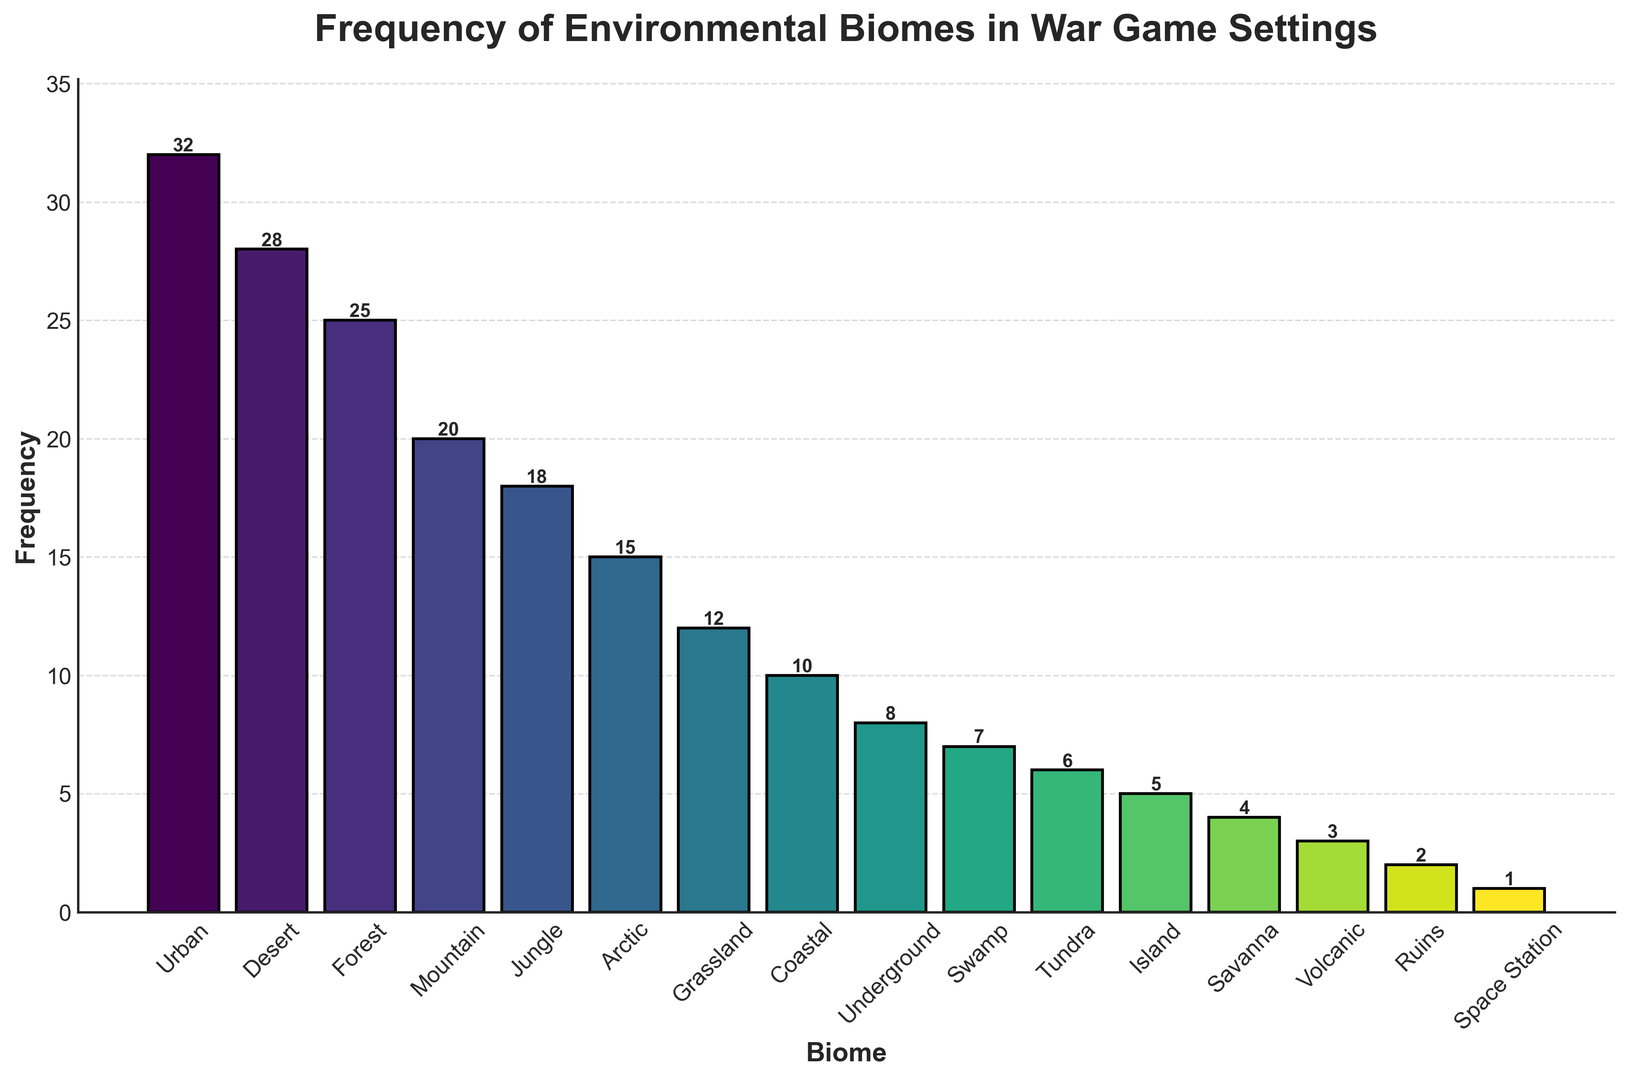What is the most frequently used biome in war game settings? The Urban biome has the tallest bar, indicating that it is used most frequently, with a frequency of 32.
Answer: Urban Which biome has the least frequency of use in the war game settings? The Space Station biome has the shortest bar, indicating that it is used the least frequently, with a frequency of 1.
Answer: Space Station How much more frequently used is Urban compared to Desert? Urban has a frequency of 32 and Desert has a frequency of 28. The difference is 32 - 28 = 4.
Answer: 4 What is the total frequency of use for Forest, Mountain, and Jungle combined? The frequencies for Forest, Mountain, and Jungle are 25, 20, and 18 respectively. The total is 25 + 20 + 18 = 63.
Answer: 63 How much more frequently is the Arctic biome used compared to the Grassland biome? The frequency of the Arctic biome is 15 and the frequency of the Grassland biome is 12. The difference is 15 - 12 = 3.
Answer: 3 Which biomes have frequencies less than 10? The Coastal, Underground, Swamp, Tundra, Island, Savanna, Volcanic, Ruins, and Space Station biomes have frequencies of 10, 8, 7, 6, 5, 4, 3, 2, and 1, respectively. All are less than 10.
Answer: Coastal, Underground, Swamp, Tundra, Island, Savanna, Volcanic, Ruins, Space Station How does the frequency of use of the Jungle biome compare to the Arctic biome? The frequency of the Jungle biome is 18 and the frequency of the Arctic biome is 15. Jungle is used more frequently by a difference of 18 - 15 = 3.
Answer: Jungle is used 3 more times What is the average frequency of use across all biomes? Adding all frequencies: 32 + 28 + 25 + 20 + 18 + 15 + 12 + 10 + 8 + 7 + 6 + 5 + 4 + 3 + 2 + 1 = 196. There are 17 biomes, so the average frequency is 196 / 17 ≈ 11.53.
Answer: 11.53 Which biome frequencies are more than twice that of the Island biome? Twice the frequency of the Island biome is 2 * 5 = 10. Biomes with frequencies greater than 10 are Urban (32), Desert (28), Forest (25), Mountain (20), Jungle (18), and Arctic (15).
Answer: Urban, Desert, Forest, Mountain, Jungle, Arctic What's the sum of the frequencies for all biomes with a frequency higher than 20? The biomes with frequencies higher than 20 are Urban (32), Desert (28), and Forest (25). The total is 32 + 28 + 25 = 85.
Answer: 85 